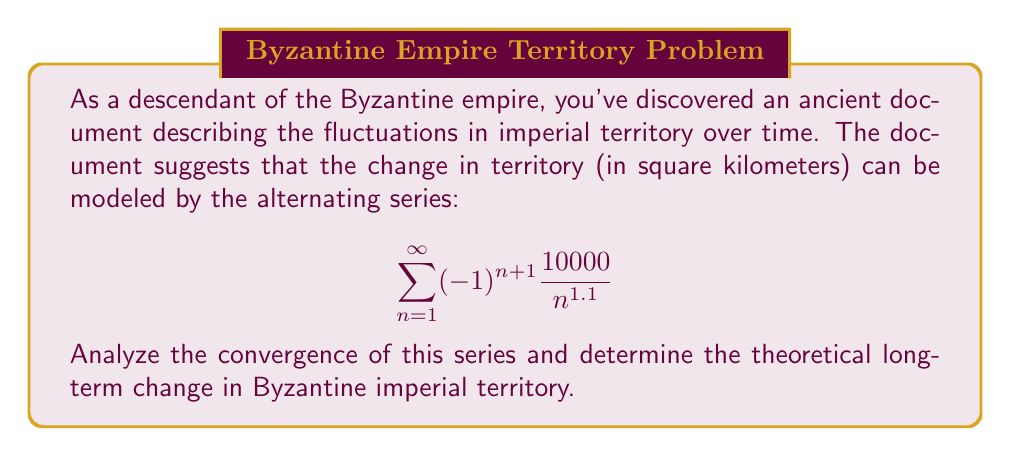What is the answer to this math problem? To analyze the convergence of this alternating series, we'll use the Alternating Series Test.

1) First, let's define $a_n = \frac{10000}{n^{1.1}}$

2) For the Alternating Series Test, we need to check two conditions:
   a) $\lim_{n \to \infty} a_n = 0$
   b) $a_n$ is decreasing for all $n \geq$ some $N$

3) Let's check condition (a):
   $$\lim_{n \to \infty} a_n = \lim_{n \to \infty} \frac{10000}{n^{1.1}} = 0$$
   This is true because $1.1 > 1$, so $n^{1.1}$ grows faster than $n$.

4) For condition (b), we can show $a_n$ is decreasing by proving $a_n > a_{n+1}$ for all $n \geq 1$:
   $$\frac{10000}{n^{1.1}} > \frac{10000}{(n+1)^{1.1}}$$
   This is true for all $n \geq 1$ because $n < n+1$.

5) Since both conditions are met, the series converges by the Alternating Series Test.

6) To find the sum of the series, we can use the alternating series estimation theorem. The error is bounded by the first neglected term. So if we take the first term, the error is less than the absolute value of the second term:

   $$\left|\sum_{n=1}^{\infty} (-1)^{n+1} \frac{10000}{n^{1.1}} - 10000\right| < \frac{10000}{2^{1.1}} \approx 4641.59$$

Therefore, the long-term change in Byzantine imperial territory is between 5358.41 and 14641.59 square kilometers.
Answer: The series converges. The long-term change in Byzantine imperial territory is approximately 10000 ± 4641.59 square kilometers. 